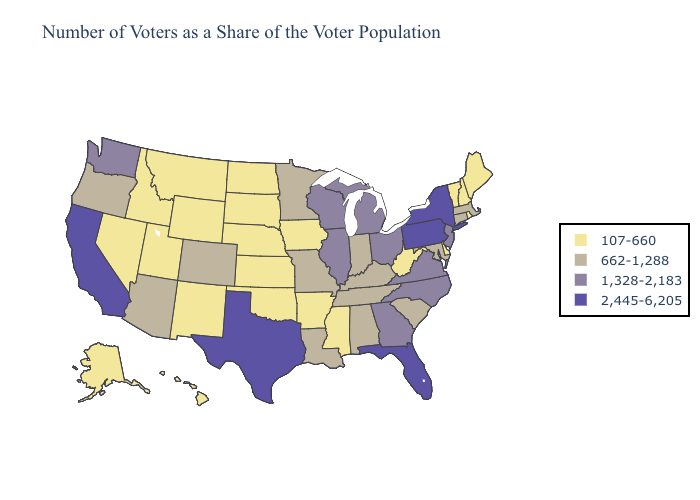What is the lowest value in the South?
Short answer required. 107-660. What is the lowest value in states that border North Carolina?
Write a very short answer. 662-1,288. Name the states that have a value in the range 2,445-6,205?
Short answer required. California, Florida, New York, Pennsylvania, Texas. Does Kentucky have the lowest value in the USA?
Keep it brief. No. Does Kentucky have the lowest value in the USA?
Short answer required. No. What is the lowest value in states that border Mississippi?
Write a very short answer. 107-660. Which states hav the highest value in the South?
Short answer required. Florida, Texas. Name the states that have a value in the range 1,328-2,183?
Write a very short answer. Georgia, Illinois, Michigan, New Jersey, North Carolina, Ohio, Virginia, Washington, Wisconsin. What is the value of Arkansas?
Write a very short answer. 107-660. Name the states that have a value in the range 107-660?
Answer briefly. Alaska, Arkansas, Delaware, Hawaii, Idaho, Iowa, Kansas, Maine, Mississippi, Montana, Nebraska, Nevada, New Hampshire, New Mexico, North Dakota, Oklahoma, Rhode Island, South Dakota, Utah, Vermont, West Virginia, Wyoming. Is the legend a continuous bar?
Quick response, please. No. Among the states that border New York , which have the lowest value?
Be succinct. Vermont. What is the value of North Dakota?
Give a very brief answer. 107-660. Among the states that border Michigan , does Ohio have the highest value?
Quick response, please. Yes. 